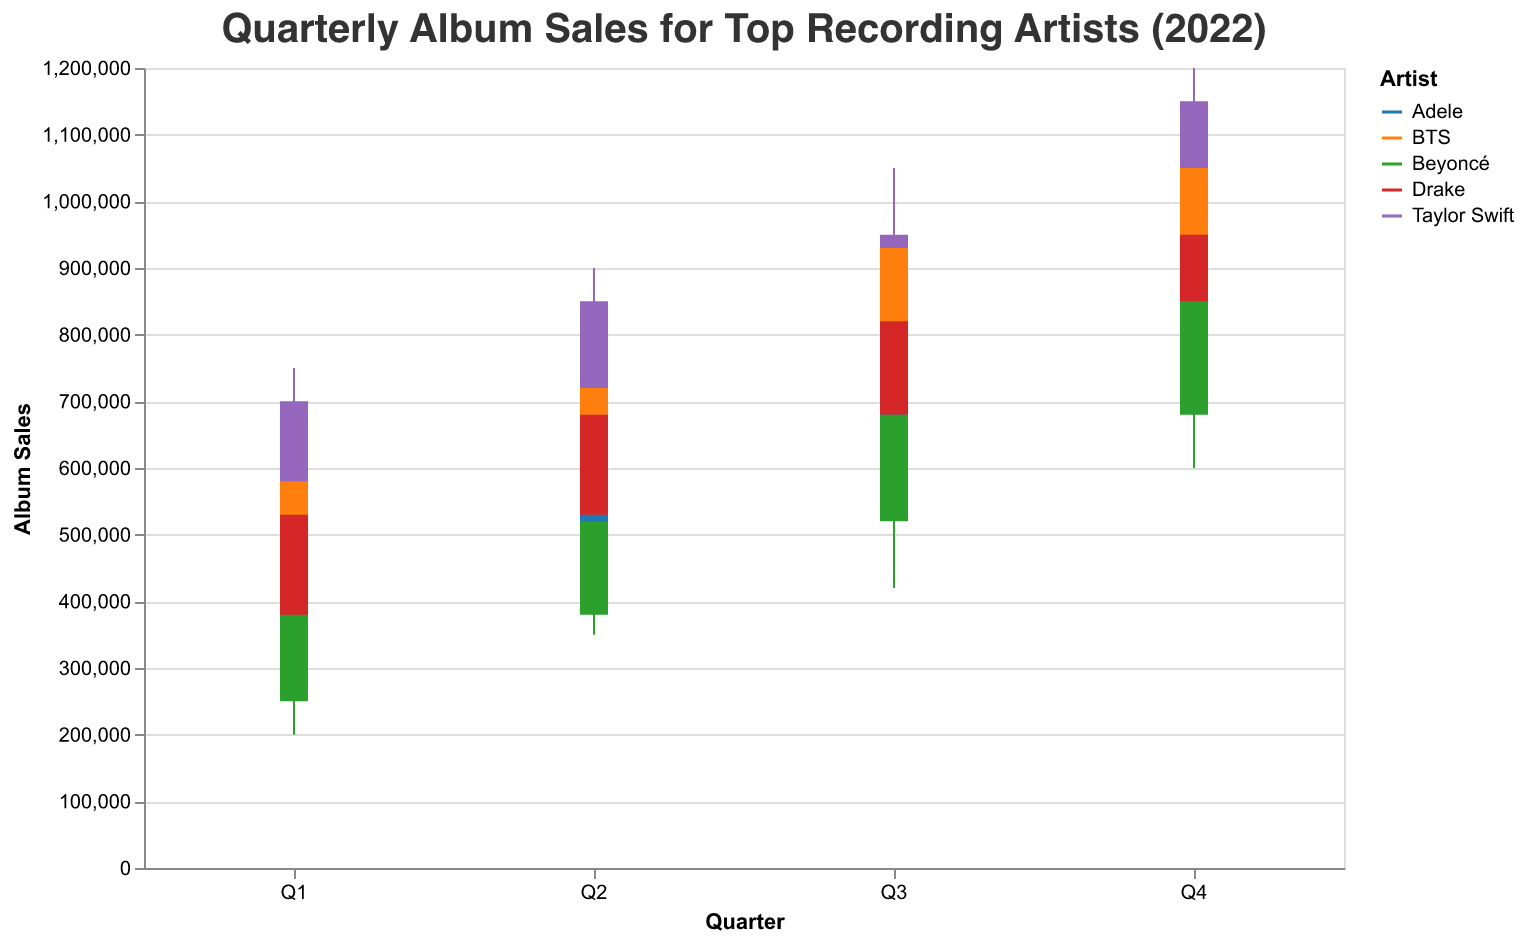What's the title of the plot? The title is often located at the top of the plot and provides a description of what the figure represents. Here, it displays "Quarterly Album Sales for Top Recording Artists (2022)".
Answer: Quarterly Album Sales for Top Recording Artists (2022) How many artists are represented in the plot? The plot's legend uses different colors to represent each artist. By counting these unique colors, we can determine the number of artists. There are five distinct colors for Taylor Swift, BTS, Adele, Drake, and Beyoncé.
Answer: 5 In which quarter did Taylor Swift have the highest closing album sales? To find this, we look at the closing sales (upper end of the bars) for Taylor Swift and compare across quarters. Taylor Swift’s highest closing sales are in Q4, where it reaches 1,150,000.
Answer: Q4 Which artist had the lowest minimum sales in Q1? By examining the bottom of the candlestick for each artist in Q1, we can determine the minimum sales. Beyoncé had the lowest minimum sales with 200,000.
Answer: Beyoncé What are the min and max sales for Adele in Q3? The candlesticks show the range from the lowest value (min) to the highest value (max). For Adele in Q3, the min sales are 550,000 and the max sales are 750,000.
Answer: 550,000 and 750,000 Which artist experienced the largest increase in closing sales from Q1 to Q4? To answer this, we calculate the difference between the closing sales in Q4 and Q1 for each artist. Taylor Swift increased from 700,000 in Q1 to 1,150,000 in Q4, resulting in an increase of 450,000, which is the largest among the artists.
Answer: Taylor Swift Did any artist experience a decrease in closing sales in any quarter? A decrease is seen when the closing sale of a quarter is less than the opening sale of the next. No visible decrease occurs for any artist across quarters as each bar from Q1 to Q4 is increasing.
Answer: No Which artist had the highest max sales in Q3? The top of the candlestick in Q3 will indicate the max sales. Taylor Swift had the highest max sales in Q3 at 1,050,000.
Answer: Taylor Swift 